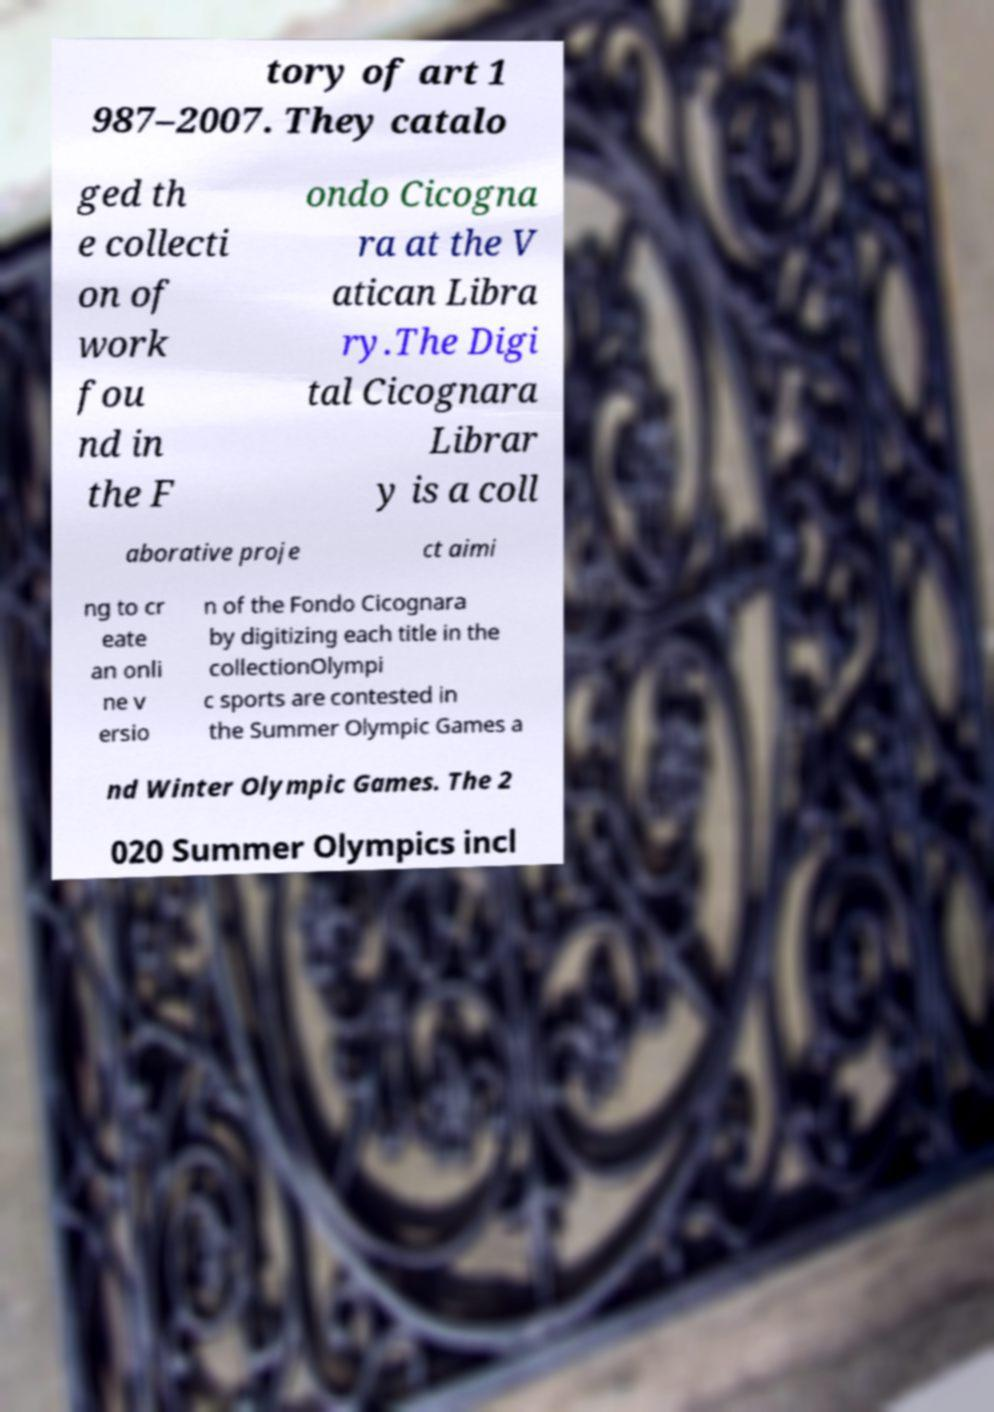Could you extract and type out the text from this image? tory of art 1 987–2007. They catalo ged th e collecti on of work fou nd in the F ondo Cicogna ra at the V atican Libra ry.The Digi tal Cicognara Librar y is a coll aborative proje ct aimi ng to cr eate an onli ne v ersio n of the Fondo Cicognara by digitizing each title in the collectionOlympi c sports are contested in the Summer Olympic Games a nd Winter Olympic Games. The 2 020 Summer Olympics incl 